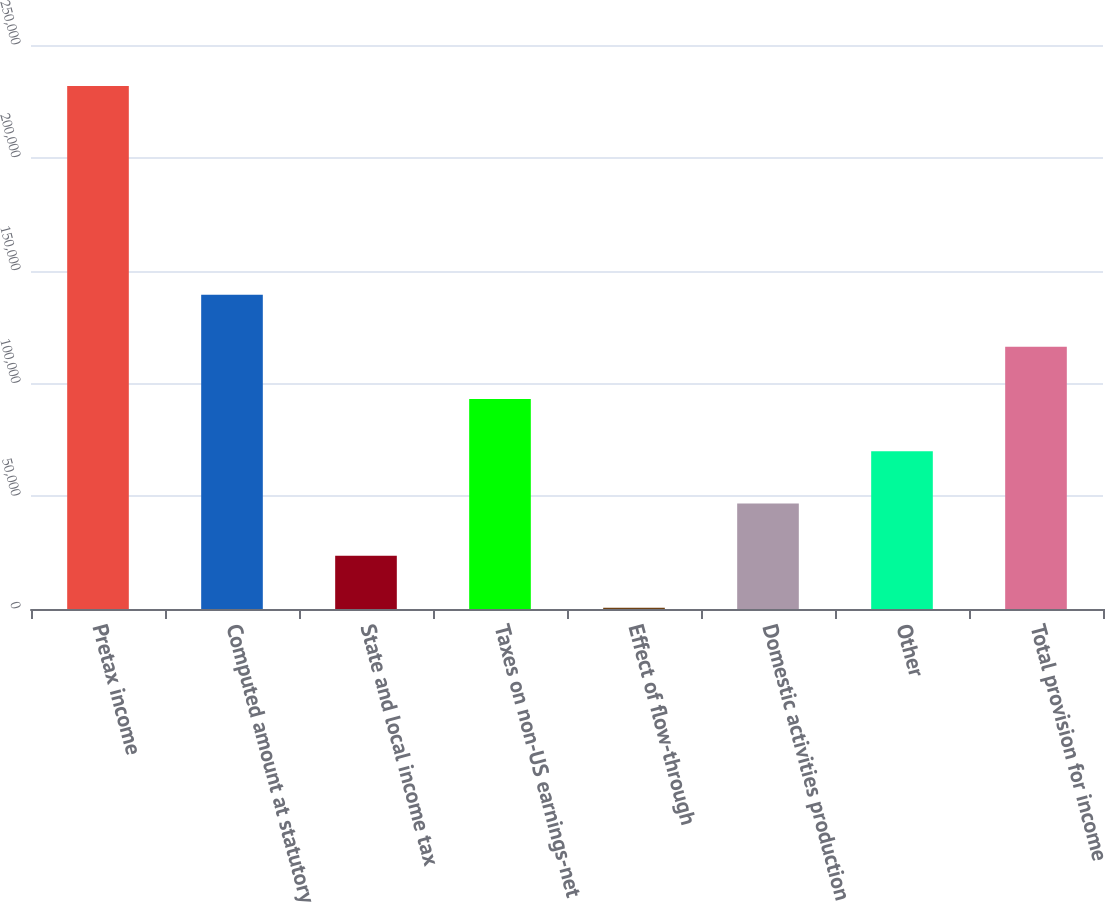Convert chart to OTSL. <chart><loc_0><loc_0><loc_500><loc_500><bar_chart><fcel>Pretax income<fcel>Computed amount at statutory<fcel>State and local income tax<fcel>Taxes on non-US earnings-net<fcel>Effect of flow-through<fcel>Domestic activities production<fcel>Other<fcel>Total provision for income<nl><fcel>231874<fcel>139331<fcel>23651.8<fcel>93059.2<fcel>516<fcel>46787.6<fcel>69923.4<fcel>116195<nl></chart> 